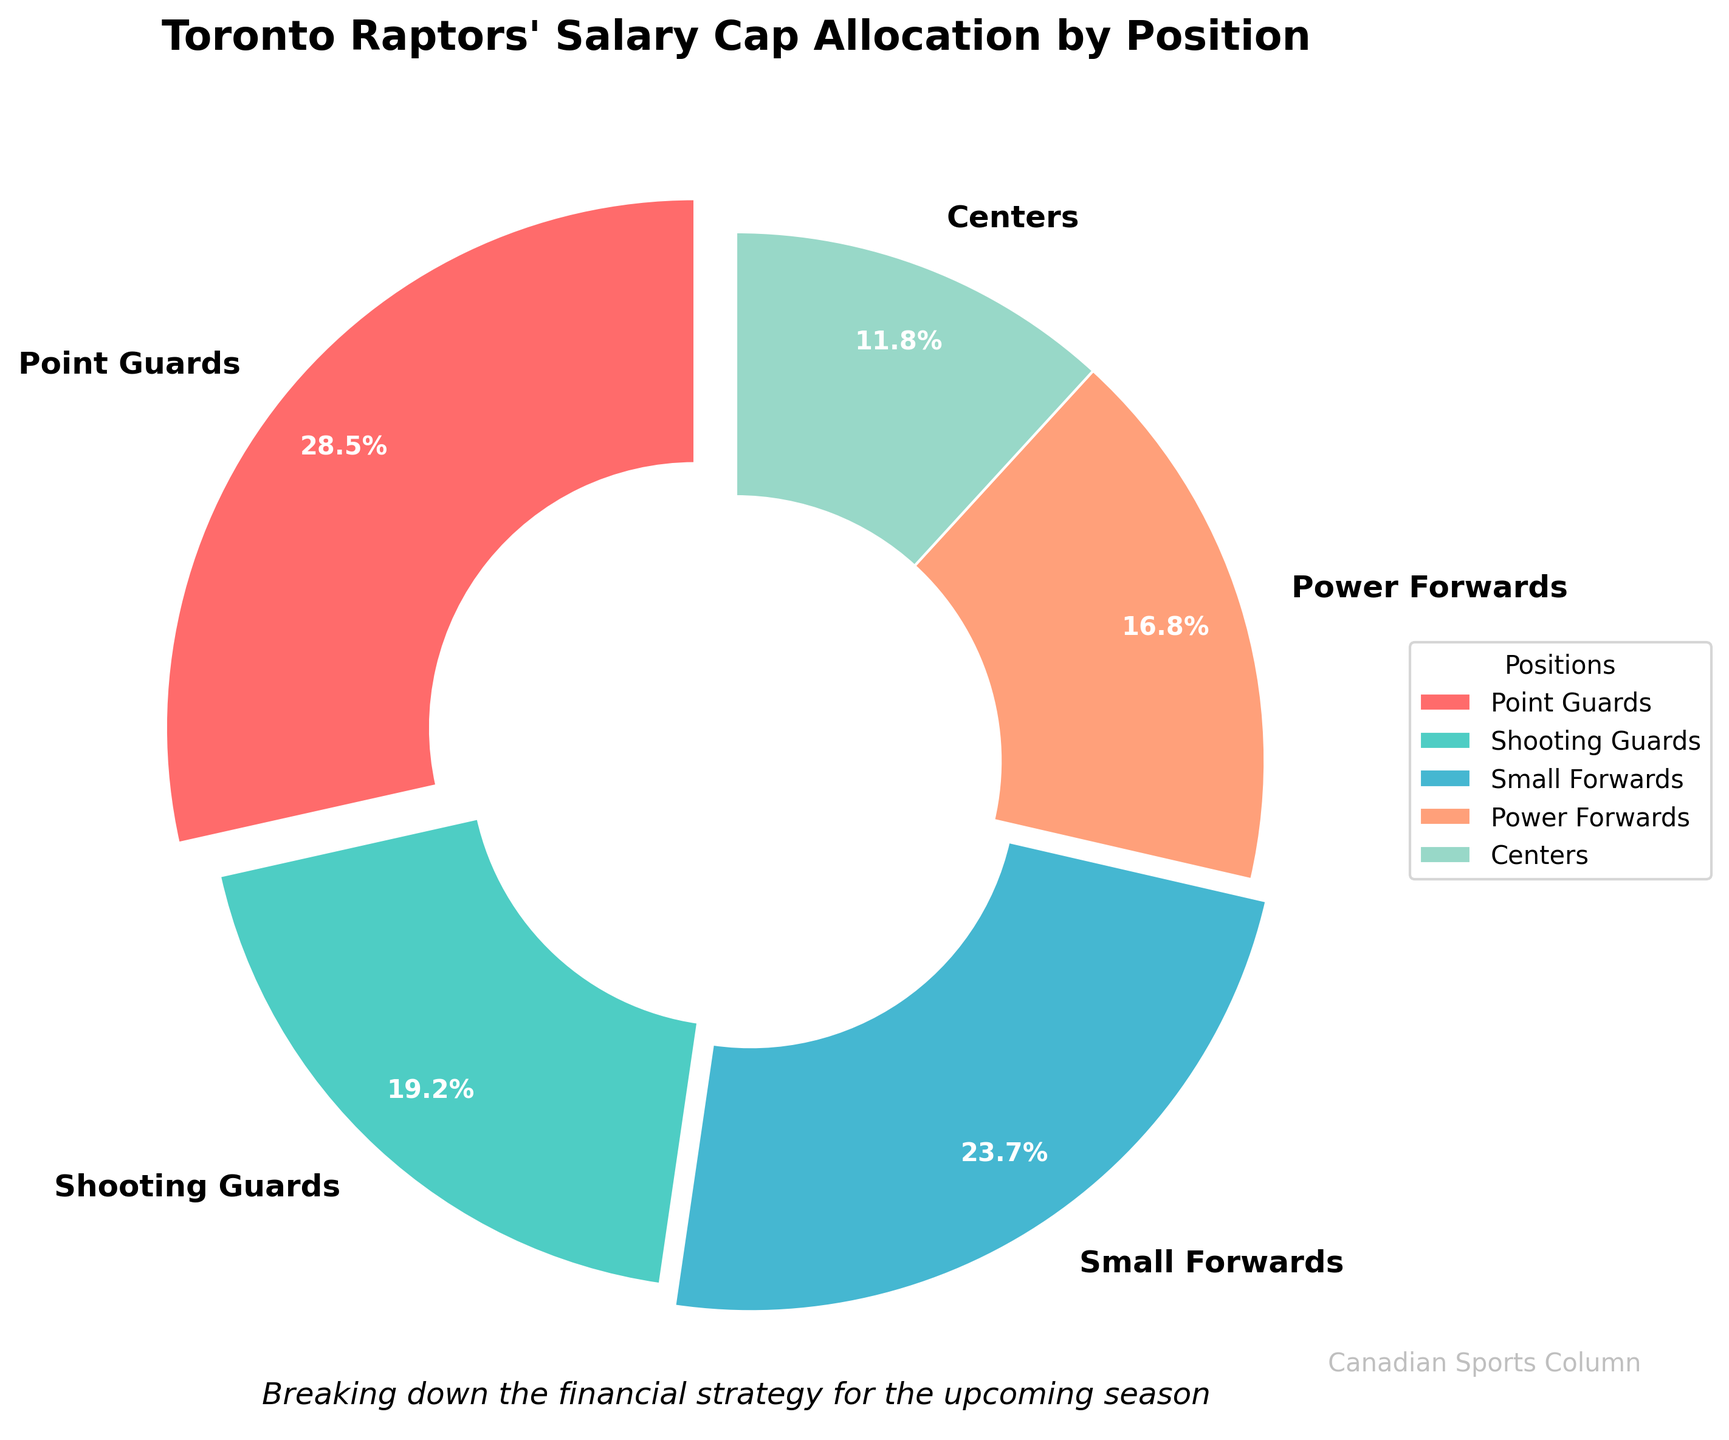Which position has the highest salary cap allocation? The color red represents Point Guards, which occupy the largest wedge in the pie chart. The allocation is 28.5%.
Answer: Point Guards Which positions have salary cap allocations greater than 20%? Point Guards (28.5%) and Small Forwards (23.7%) both have allocations over 20%.
Answer: Point Guards, Small Forwards What is the difference in salary cap allocation between Point Guards and Centers? Point Guards have a 28.5% allocation and Centers have an 11.8% allocation. The difference is 28.5 - 11.8, which equals 16.7%.
Answer: 16.7% Rank the positions in terms of their salary cap allocations from highest to lowest. Point Guards (28.5%), Small Forwards (23.7%), Shooting Guards (19.2%), Power Forwards (16.8%), Centers (11.8%).
Answer: Point Guards, Small Forwards, Shooting Guards, Power Forwards, Centers What proportion of the salary cap allocation is spent on forwards (Small Forwards and Power Forwards combined)? Small Forwards have 23.7% and Power Forwards have 16.8%. Sum these to get 23.7 + 16.8, which equals 40.5%.
Answer: 40.5% Which position has the smallest salary cap allocation? The color representing Centers occupies the smallest wedge in the pie chart and has an 11.8% allocation.
Answer: Centers How much more is allocated to Small Forwards compared to Shooting Guards? Small Forwards have a 23.7% allocation and Shooting Guards have 19.2%. The difference is 23.7 - 19.2, which equals 4.5%.
Answer: 4.5% Are Shooting Guards allocated more cap space than Centers? Yes, Shooting Guards have 19.2% while Centers have 11.8%. 19.2 is indeed greater than 11.8.
Answer: Yes What percentage of the salary cap is allocated to guards (Point Guards and Shooting Guards combined)? Point Guards have 28.5% and Shooting Guards have 19.2%. Sum these to get 28.5 + 19.2, which equals 47.7%.
Answer: 47.7% Which position segment is displayed in green? The color green represents Shooting Guards in the pie chart.
Answer: Shooting Guards 